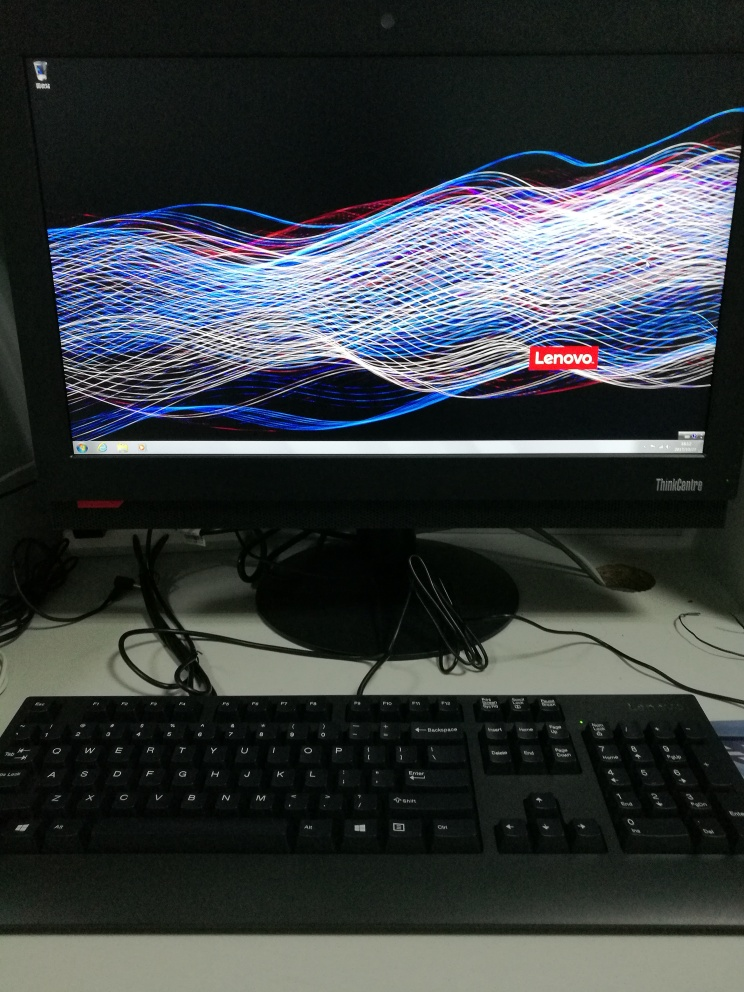What other objects can be observed in the image besides the monitor? Besides the monitor displaying colorful patterns, a black keyboard is visible in the foreground, and there are some cables and a reflection of a round object, possibly a desk lamp or a similar item, behind the monitor. 